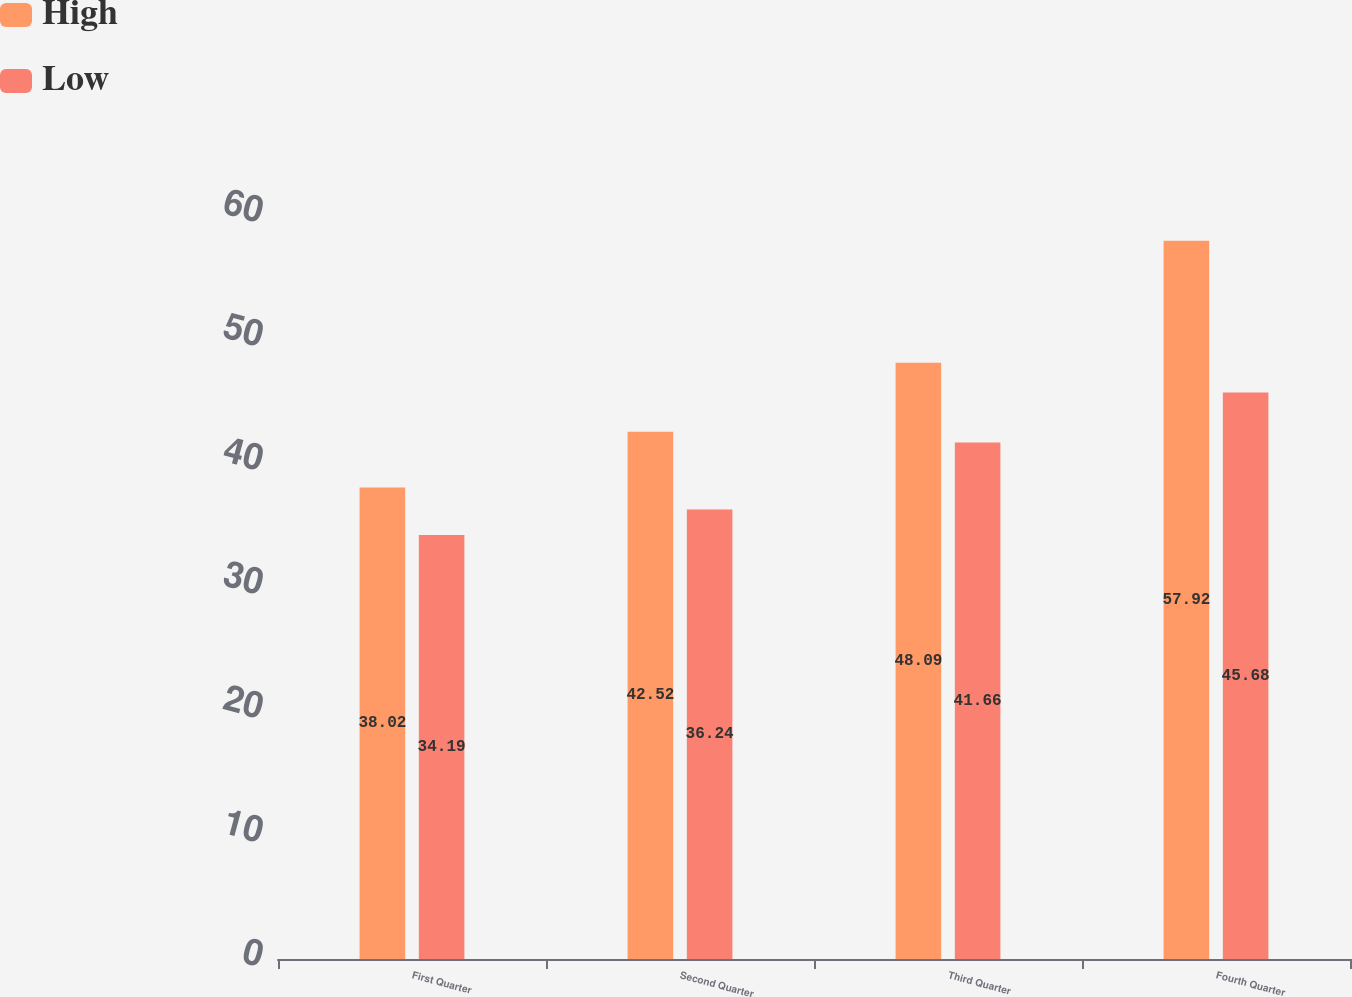<chart> <loc_0><loc_0><loc_500><loc_500><stacked_bar_chart><ecel><fcel>First Quarter<fcel>Second Quarter<fcel>Third Quarter<fcel>Fourth Quarter<nl><fcel>High<fcel>38.02<fcel>42.52<fcel>48.09<fcel>57.92<nl><fcel>Low<fcel>34.19<fcel>36.24<fcel>41.66<fcel>45.68<nl></chart> 